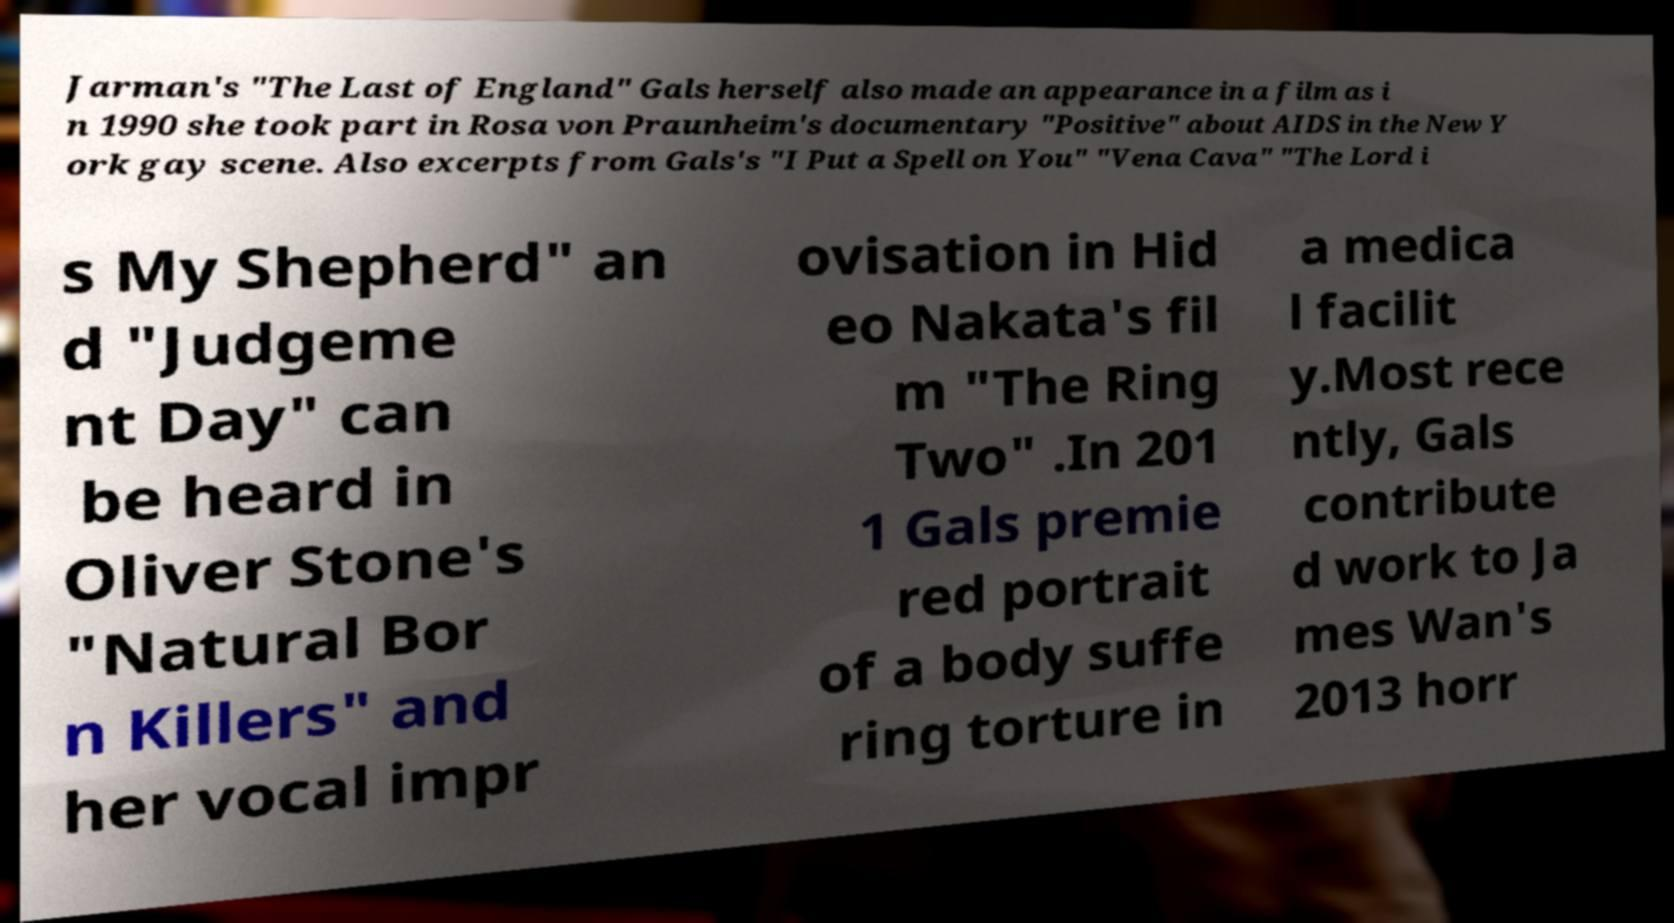Please identify and transcribe the text found in this image. Jarman's "The Last of England" Gals herself also made an appearance in a film as i n 1990 she took part in Rosa von Praunheim's documentary "Positive" about AIDS in the New Y ork gay scene. Also excerpts from Gals's "I Put a Spell on You" "Vena Cava" "The Lord i s My Shepherd" an d "Judgeme nt Day" can be heard in Oliver Stone's "Natural Bor n Killers" and her vocal impr ovisation in Hid eo Nakata's fil m "The Ring Two" .In 201 1 Gals premie red portrait of a body suffe ring torture in a medica l facilit y.Most rece ntly, Gals contribute d work to Ja mes Wan's 2013 horr 